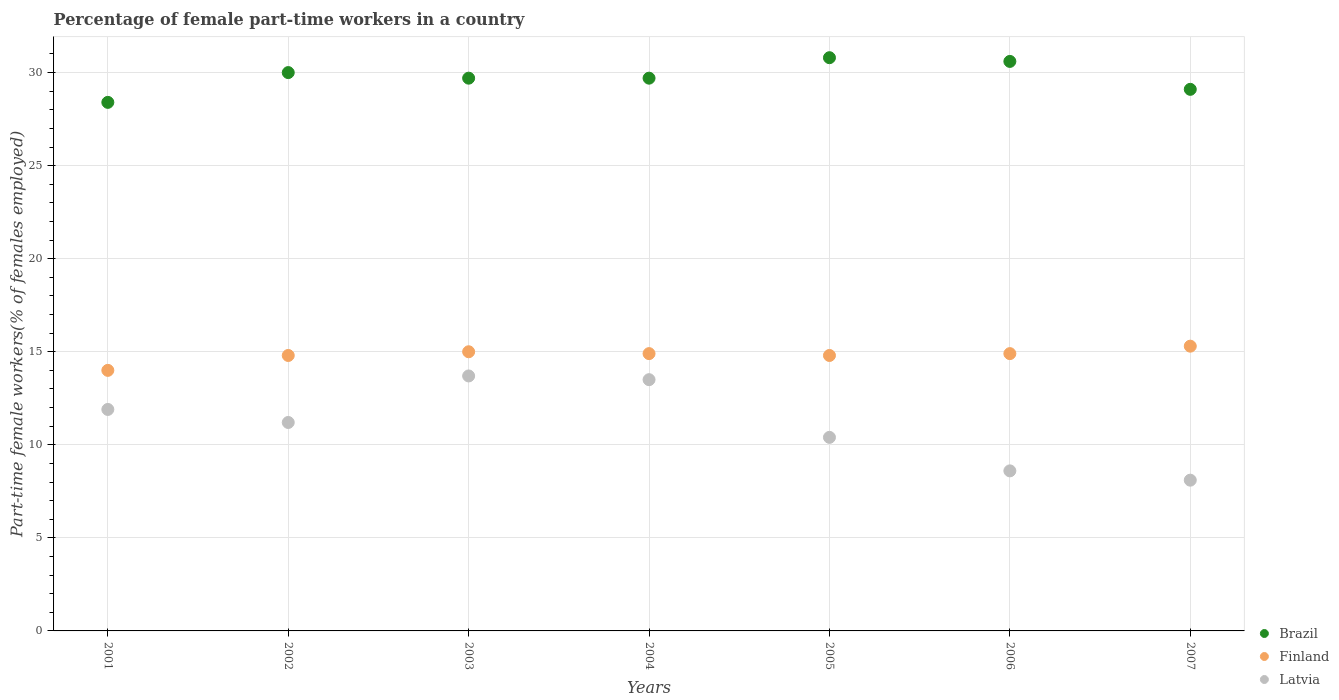How many different coloured dotlines are there?
Your answer should be very brief. 3. Is the number of dotlines equal to the number of legend labels?
Ensure brevity in your answer.  Yes. What is the percentage of female part-time workers in Latvia in 2006?
Provide a succinct answer. 8.6. Across all years, what is the maximum percentage of female part-time workers in Brazil?
Offer a very short reply. 30.8. Across all years, what is the minimum percentage of female part-time workers in Latvia?
Give a very brief answer. 8.1. What is the total percentage of female part-time workers in Latvia in the graph?
Make the answer very short. 77.4. What is the difference between the percentage of female part-time workers in Finland in 2001 and that in 2006?
Your answer should be very brief. -0.9. What is the difference between the percentage of female part-time workers in Finland in 2004 and the percentage of female part-time workers in Brazil in 2002?
Make the answer very short. -15.1. What is the average percentage of female part-time workers in Brazil per year?
Provide a succinct answer. 29.76. In the year 2006, what is the difference between the percentage of female part-time workers in Finland and percentage of female part-time workers in Latvia?
Offer a very short reply. 6.3. In how many years, is the percentage of female part-time workers in Finland greater than 4 %?
Your answer should be very brief. 7. What is the ratio of the percentage of female part-time workers in Latvia in 2004 to that in 2005?
Give a very brief answer. 1.3. Is the percentage of female part-time workers in Latvia in 2001 less than that in 2002?
Ensure brevity in your answer.  No. Is the difference between the percentage of female part-time workers in Finland in 2001 and 2003 greater than the difference between the percentage of female part-time workers in Latvia in 2001 and 2003?
Give a very brief answer. Yes. What is the difference between the highest and the second highest percentage of female part-time workers in Brazil?
Your answer should be very brief. 0.2. What is the difference between the highest and the lowest percentage of female part-time workers in Latvia?
Ensure brevity in your answer.  5.6. In how many years, is the percentage of female part-time workers in Latvia greater than the average percentage of female part-time workers in Latvia taken over all years?
Your response must be concise. 4. Is the sum of the percentage of female part-time workers in Latvia in 2006 and 2007 greater than the maximum percentage of female part-time workers in Finland across all years?
Keep it short and to the point. Yes. Is it the case that in every year, the sum of the percentage of female part-time workers in Latvia and percentage of female part-time workers in Brazil  is greater than the percentage of female part-time workers in Finland?
Your answer should be very brief. Yes. Does the percentage of female part-time workers in Latvia monotonically increase over the years?
Provide a short and direct response. No. Is the percentage of female part-time workers in Brazil strictly greater than the percentage of female part-time workers in Finland over the years?
Provide a succinct answer. Yes. Is the percentage of female part-time workers in Finland strictly less than the percentage of female part-time workers in Brazil over the years?
Ensure brevity in your answer.  Yes. How many years are there in the graph?
Provide a short and direct response. 7. What is the difference between two consecutive major ticks on the Y-axis?
Your response must be concise. 5. Are the values on the major ticks of Y-axis written in scientific E-notation?
Make the answer very short. No. Does the graph contain any zero values?
Your answer should be very brief. No. Where does the legend appear in the graph?
Your response must be concise. Bottom right. How many legend labels are there?
Your answer should be very brief. 3. What is the title of the graph?
Offer a very short reply. Percentage of female part-time workers in a country. Does "Aruba" appear as one of the legend labels in the graph?
Offer a very short reply. No. What is the label or title of the X-axis?
Offer a very short reply. Years. What is the label or title of the Y-axis?
Ensure brevity in your answer.  Part-time female workers(% of females employed). What is the Part-time female workers(% of females employed) of Brazil in 2001?
Provide a short and direct response. 28.4. What is the Part-time female workers(% of females employed) of Finland in 2001?
Give a very brief answer. 14. What is the Part-time female workers(% of females employed) of Latvia in 2001?
Provide a short and direct response. 11.9. What is the Part-time female workers(% of females employed) of Finland in 2002?
Offer a very short reply. 14.8. What is the Part-time female workers(% of females employed) in Latvia in 2002?
Keep it short and to the point. 11.2. What is the Part-time female workers(% of females employed) in Brazil in 2003?
Your answer should be very brief. 29.7. What is the Part-time female workers(% of females employed) in Finland in 2003?
Ensure brevity in your answer.  15. What is the Part-time female workers(% of females employed) in Latvia in 2003?
Keep it short and to the point. 13.7. What is the Part-time female workers(% of females employed) of Brazil in 2004?
Make the answer very short. 29.7. What is the Part-time female workers(% of females employed) in Finland in 2004?
Your answer should be very brief. 14.9. What is the Part-time female workers(% of females employed) in Brazil in 2005?
Keep it short and to the point. 30.8. What is the Part-time female workers(% of females employed) in Finland in 2005?
Offer a terse response. 14.8. What is the Part-time female workers(% of females employed) in Latvia in 2005?
Provide a short and direct response. 10.4. What is the Part-time female workers(% of females employed) in Brazil in 2006?
Your response must be concise. 30.6. What is the Part-time female workers(% of females employed) in Finland in 2006?
Make the answer very short. 14.9. What is the Part-time female workers(% of females employed) of Latvia in 2006?
Your response must be concise. 8.6. What is the Part-time female workers(% of females employed) of Brazil in 2007?
Your answer should be very brief. 29.1. What is the Part-time female workers(% of females employed) of Finland in 2007?
Your answer should be very brief. 15.3. What is the Part-time female workers(% of females employed) of Latvia in 2007?
Give a very brief answer. 8.1. Across all years, what is the maximum Part-time female workers(% of females employed) of Brazil?
Your answer should be very brief. 30.8. Across all years, what is the maximum Part-time female workers(% of females employed) in Finland?
Your answer should be very brief. 15.3. Across all years, what is the maximum Part-time female workers(% of females employed) in Latvia?
Give a very brief answer. 13.7. Across all years, what is the minimum Part-time female workers(% of females employed) of Brazil?
Make the answer very short. 28.4. Across all years, what is the minimum Part-time female workers(% of females employed) of Finland?
Provide a short and direct response. 14. Across all years, what is the minimum Part-time female workers(% of females employed) of Latvia?
Offer a very short reply. 8.1. What is the total Part-time female workers(% of females employed) of Brazil in the graph?
Your response must be concise. 208.3. What is the total Part-time female workers(% of females employed) in Finland in the graph?
Your answer should be compact. 103.7. What is the total Part-time female workers(% of females employed) of Latvia in the graph?
Provide a short and direct response. 77.4. What is the difference between the Part-time female workers(% of females employed) of Latvia in 2001 and that in 2002?
Your answer should be compact. 0.7. What is the difference between the Part-time female workers(% of females employed) in Latvia in 2001 and that in 2006?
Your response must be concise. 3.3. What is the difference between the Part-time female workers(% of females employed) of Finland in 2001 and that in 2007?
Keep it short and to the point. -1.3. What is the difference between the Part-time female workers(% of females employed) in Brazil in 2002 and that in 2003?
Your response must be concise. 0.3. What is the difference between the Part-time female workers(% of females employed) in Latvia in 2002 and that in 2003?
Make the answer very short. -2.5. What is the difference between the Part-time female workers(% of females employed) in Brazil in 2002 and that in 2004?
Your answer should be compact. 0.3. What is the difference between the Part-time female workers(% of females employed) of Latvia in 2002 and that in 2004?
Offer a very short reply. -2.3. What is the difference between the Part-time female workers(% of females employed) in Brazil in 2002 and that in 2005?
Offer a very short reply. -0.8. What is the difference between the Part-time female workers(% of females employed) in Finland in 2002 and that in 2005?
Make the answer very short. 0. What is the difference between the Part-time female workers(% of females employed) of Brazil in 2002 and that in 2006?
Offer a very short reply. -0.6. What is the difference between the Part-time female workers(% of females employed) in Latvia in 2002 and that in 2006?
Your answer should be very brief. 2.6. What is the difference between the Part-time female workers(% of females employed) in Brazil in 2002 and that in 2007?
Offer a very short reply. 0.9. What is the difference between the Part-time female workers(% of females employed) in Brazil in 2003 and that in 2004?
Make the answer very short. 0. What is the difference between the Part-time female workers(% of females employed) of Finland in 2003 and that in 2004?
Provide a short and direct response. 0.1. What is the difference between the Part-time female workers(% of females employed) of Brazil in 2003 and that in 2005?
Your answer should be compact. -1.1. What is the difference between the Part-time female workers(% of females employed) in Finland in 2003 and that in 2005?
Make the answer very short. 0.2. What is the difference between the Part-time female workers(% of females employed) in Finland in 2003 and that in 2006?
Provide a short and direct response. 0.1. What is the difference between the Part-time female workers(% of females employed) in Brazil in 2003 and that in 2007?
Ensure brevity in your answer.  0.6. What is the difference between the Part-time female workers(% of females employed) in Finland in 2004 and that in 2005?
Give a very brief answer. 0.1. What is the difference between the Part-time female workers(% of females employed) of Brazil in 2004 and that in 2006?
Keep it short and to the point. -0.9. What is the difference between the Part-time female workers(% of females employed) in Finland in 2004 and that in 2007?
Make the answer very short. -0.4. What is the difference between the Part-time female workers(% of females employed) in Finland in 2005 and that in 2006?
Offer a terse response. -0.1. What is the difference between the Part-time female workers(% of females employed) of Latvia in 2005 and that in 2006?
Keep it short and to the point. 1.8. What is the difference between the Part-time female workers(% of females employed) in Brazil in 2005 and that in 2007?
Offer a terse response. 1.7. What is the difference between the Part-time female workers(% of females employed) in Finland in 2005 and that in 2007?
Your response must be concise. -0.5. What is the difference between the Part-time female workers(% of females employed) in Brazil in 2006 and that in 2007?
Keep it short and to the point. 1.5. What is the difference between the Part-time female workers(% of females employed) in Brazil in 2001 and the Part-time female workers(% of females employed) in Finland in 2002?
Offer a terse response. 13.6. What is the difference between the Part-time female workers(% of females employed) in Brazil in 2001 and the Part-time female workers(% of females employed) in Latvia in 2003?
Your response must be concise. 14.7. What is the difference between the Part-time female workers(% of females employed) of Finland in 2001 and the Part-time female workers(% of females employed) of Latvia in 2003?
Offer a very short reply. 0.3. What is the difference between the Part-time female workers(% of females employed) of Finland in 2001 and the Part-time female workers(% of females employed) of Latvia in 2004?
Offer a terse response. 0.5. What is the difference between the Part-time female workers(% of females employed) in Finland in 2001 and the Part-time female workers(% of females employed) in Latvia in 2005?
Keep it short and to the point. 3.6. What is the difference between the Part-time female workers(% of females employed) in Brazil in 2001 and the Part-time female workers(% of females employed) in Latvia in 2006?
Give a very brief answer. 19.8. What is the difference between the Part-time female workers(% of females employed) of Finland in 2001 and the Part-time female workers(% of females employed) of Latvia in 2006?
Provide a succinct answer. 5.4. What is the difference between the Part-time female workers(% of females employed) in Brazil in 2001 and the Part-time female workers(% of females employed) in Finland in 2007?
Your answer should be compact. 13.1. What is the difference between the Part-time female workers(% of females employed) in Brazil in 2001 and the Part-time female workers(% of females employed) in Latvia in 2007?
Provide a succinct answer. 20.3. What is the difference between the Part-time female workers(% of females employed) in Finland in 2001 and the Part-time female workers(% of females employed) in Latvia in 2007?
Provide a succinct answer. 5.9. What is the difference between the Part-time female workers(% of females employed) of Brazil in 2002 and the Part-time female workers(% of females employed) of Finland in 2003?
Give a very brief answer. 15. What is the difference between the Part-time female workers(% of females employed) in Brazil in 2002 and the Part-time female workers(% of females employed) in Latvia in 2003?
Your answer should be compact. 16.3. What is the difference between the Part-time female workers(% of females employed) in Finland in 2002 and the Part-time female workers(% of females employed) in Latvia in 2004?
Your answer should be compact. 1.3. What is the difference between the Part-time female workers(% of females employed) of Brazil in 2002 and the Part-time female workers(% of females employed) of Finland in 2005?
Make the answer very short. 15.2. What is the difference between the Part-time female workers(% of females employed) of Brazil in 2002 and the Part-time female workers(% of females employed) of Latvia in 2005?
Offer a terse response. 19.6. What is the difference between the Part-time female workers(% of females employed) of Brazil in 2002 and the Part-time female workers(% of females employed) of Finland in 2006?
Your answer should be very brief. 15.1. What is the difference between the Part-time female workers(% of females employed) in Brazil in 2002 and the Part-time female workers(% of females employed) in Latvia in 2006?
Give a very brief answer. 21.4. What is the difference between the Part-time female workers(% of females employed) in Finland in 2002 and the Part-time female workers(% of females employed) in Latvia in 2006?
Offer a terse response. 6.2. What is the difference between the Part-time female workers(% of females employed) in Brazil in 2002 and the Part-time female workers(% of females employed) in Latvia in 2007?
Provide a succinct answer. 21.9. What is the difference between the Part-time female workers(% of females employed) of Brazil in 2003 and the Part-time female workers(% of females employed) of Finland in 2004?
Keep it short and to the point. 14.8. What is the difference between the Part-time female workers(% of females employed) in Brazil in 2003 and the Part-time female workers(% of females employed) in Latvia in 2004?
Your answer should be very brief. 16.2. What is the difference between the Part-time female workers(% of females employed) in Finland in 2003 and the Part-time female workers(% of females employed) in Latvia in 2004?
Your answer should be very brief. 1.5. What is the difference between the Part-time female workers(% of females employed) in Brazil in 2003 and the Part-time female workers(% of females employed) in Finland in 2005?
Ensure brevity in your answer.  14.9. What is the difference between the Part-time female workers(% of females employed) in Brazil in 2003 and the Part-time female workers(% of females employed) in Latvia in 2005?
Make the answer very short. 19.3. What is the difference between the Part-time female workers(% of females employed) in Brazil in 2003 and the Part-time female workers(% of females employed) in Latvia in 2006?
Your answer should be compact. 21.1. What is the difference between the Part-time female workers(% of females employed) of Brazil in 2003 and the Part-time female workers(% of females employed) of Finland in 2007?
Your response must be concise. 14.4. What is the difference between the Part-time female workers(% of females employed) in Brazil in 2003 and the Part-time female workers(% of females employed) in Latvia in 2007?
Give a very brief answer. 21.6. What is the difference between the Part-time female workers(% of females employed) of Brazil in 2004 and the Part-time female workers(% of females employed) of Latvia in 2005?
Give a very brief answer. 19.3. What is the difference between the Part-time female workers(% of females employed) in Brazil in 2004 and the Part-time female workers(% of females employed) in Latvia in 2006?
Give a very brief answer. 21.1. What is the difference between the Part-time female workers(% of females employed) in Finland in 2004 and the Part-time female workers(% of females employed) in Latvia in 2006?
Provide a succinct answer. 6.3. What is the difference between the Part-time female workers(% of females employed) in Brazil in 2004 and the Part-time female workers(% of females employed) in Finland in 2007?
Your answer should be compact. 14.4. What is the difference between the Part-time female workers(% of females employed) of Brazil in 2004 and the Part-time female workers(% of females employed) of Latvia in 2007?
Offer a terse response. 21.6. What is the difference between the Part-time female workers(% of females employed) of Finland in 2005 and the Part-time female workers(% of females employed) of Latvia in 2006?
Provide a succinct answer. 6.2. What is the difference between the Part-time female workers(% of females employed) of Brazil in 2005 and the Part-time female workers(% of females employed) of Latvia in 2007?
Give a very brief answer. 22.7. What is the average Part-time female workers(% of females employed) of Brazil per year?
Your answer should be very brief. 29.76. What is the average Part-time female workers(% of females employed) of Finland per year?
Your answer should be compact. 14.81. What is the average Part-time female workers(% of females employed) in Latvia per year?
Provide a short and direct response. 11.06. In the year 2001, what is the difference between the Part-time female workers(% of females employed) of Brazil and Part-time female workers(% of females employed) of Latvia?
Make the answer very short. 16.5. In the year 2001, what is the difference between the Part-time female workers(% of females employed) in Finland and Part-time female workers(% of females employed) in Latvia?
Ensure brevity in your answer.  2.1. In the year 2002, what is the difference between the Part-time female workers(% of females employed) of Brazil and Part-time female workers(% of females employed) of Latvia?
Ensure brevity in your answer.  18.8. In the year 2003, what is the difference between the Part-time female workers(% of females employed) in Finland and Part-time female workers(% of females employed) in Latvia?
Provide a short and direct response. 1.3. In the year 2004, what is the difference between the Part-time female workers(% of females employed) in Brazil and Part-time female workers(% of females employed) in Finland?
Offer a terse response. 14.8. In the year 2004, what is the difference between the Part-time female workers(% of females employed) in Brazil and Part-time female workers(% of females employed) in Latvia?
Make the answer very short. 16.2. In the year 2005, what is the difference between the Part-time female workers(% of females employed) of Brazil and Part-time female workers(% of females employed) of Finland?
Ensure brevity in your answer.  16. In the year 2005, what is the difference between the Part-time female workers(% of females employed) in Brazil and Part-time female workers(% of females employed) in Latvia?
Your response must be concise. 20.4. In the year 2006, what is the difference between the Part-time female workers(% of females employed) in Finland and Part-time female workers(% of females employed) in Latvia?
Make the answer very short. 6.3. In the year 2007, what is the difference between the Part-time female workers(% of females employed) of Brazil and Part-time female workers(% of females employed) of Latvia?
Provide a short and direct response. 21. In the year 2007, what is the difference between the Part-time female workers(% of females employed) in Finland and Part-time female workers(% of females employed) in Latvia?
Give a very brief answer. 7.2. What is the ratio of the Part-time female workers(% of females employed) of Brazil in 2001 to that in 2002?
Make the answer very short. 0.95. What is the ratio of the Part-time female workers(% of females employed) in Finland in 2001 to that in 2002?
Your answer should be very brief. 0.95. What is the ratio of the Part-time female workers(% of females employed) in Latvia in 2001 to that in 2002?
Your answer should be very brief. 1.06. What is the ratio of the Part-time female workers(% of females employed) of Brazil in 2001 to that in 2003?
Make the answer very short. 0.96. What is the ratio of the Part-time female workers(% of females employed) in Finland in 2001 to that in 2003?
Ensure brevity in your answer.  0.93. What is the ratio of the Part-time female workers(% of females employed) of Latvia in 2001 to that in 2003?
Provide a short and direct response. 0.87. What is the ratio of the Part-time female workers(% of females employed) of Brazil in 2001 to that in 2004?
Offer a very short reply. 0.96. What is the ratio of the Part-time female workers(% of females employed) of Finland in 2001 to that in 2004?
Your response must be concise. 0.94. What is the ratio of the Part-time female workers(% of females employed) of Latvia in 2001 to that in 2004?
Your answer should be very brief. 0.88. What is the ratio of the Part-time female workers(% of females employed) in Brazil in 2001 to that in 2005?
Your answer should be very brief. 0.92. What is the ratio of the Part-time female workers(% of females employed) of Finland in 2001 to that in 2005?
Make the answer very short. 0.95. What is the ratio of the Part-time female workers(% of females employed) of Latvia in 2001 to that in 2005?
Give a very brief answer. 1.14. What is the ratio of the Part-time female workers(% of females employed) of Brazil in 2001 to that in 2006?
Provide a succinct answer. 0.93. What is the ratio of the Part-time female workers(% of females employed) of Finland in 2001 to that in 2006?
Your answer should be compact. 0.94. What is the ratio of the Part-time female workers(% of females employed) in Latvia in 2001 to that in 2006?
Offer a terse response. 1.38. What is the ratio of the Part-time female workers(% of females employed) in Brazil in 2001 to that in 2007?
Offer a terse response. 0.98. What is the ratio of the Part-time female workers(% of females employed) of Finland in 2001 to that in 2007?
Give a very brief answer. 0.92. What is the ratio of the Part-time female workers(% of females employed) in Latvia in 2001 to that in 2007?
Your response must be concise. 1.47. What is the ratio of the Part-time female workers(% of females employed) in Finland in 2002 to that in 2003?
Your answer should be compact. 0.99. What is the ratio of the Part-time female workers(% of females employed) in Latvia in 2002 to that in 2003?
Your answer should be very brief. 0.82. What is the ratio of the Part-time female workers(% of females employed) of Brazil in 2002 to that in 2004?
Keep it short and to the point. 1.01. What is the ratio of the Part-time female workers(% of females employed) in Finland in 2002 to that in 2004?
Your response must be concise. 0.99. What is the ratio of the Part-time female workers(% of females employed) of Latvia in 2002 to that in 2004?
Offer a terse response. 0.83. What is the ratio of the Part-time female workers(% of females employed) of Brazil in 2002 to that in 2006?
Provide a succinct answer. 0.98. What is the ratio of the Part-time female workers(% of females employed) in Finland in 2002 to that in 2006?
Ensure brevity in your answer.  0.99. What is the ratio of the Part-time female workers(% of females employed) in Latvia in 2002 to that in 2006?
Ensure brevity in your answer.  1.3. What is the ratio of the Part-time female workers(% of females employed) in Brazil in 2002 to that in 2007?
Keep it short and to the point. 1.03. What is the ratio of the Part-time female workers(% of females employed) in Finland in 2002 to that in 2007?
Offer a terse response. 0.97. What is the ratio of the Part-time female workers(% of females employed) of Latvia in 2002 to that in 2007?
Provide a short and direct response. 1.38. What is the ratio of the Part-time female workers(% of females employed) in Finland in 2003 to that in 2004?
Ensure brevity in your answer.  1.01. What is the ratio of the Part-time female workers(% of females employed) of Latvia in 2003 to that in 2004?
Offer a terse response. 1.01. What is the ratio of the Part-time female workers(% of females employed) of Brazil in 2003 to that in 2005?
Keep it short and to the point. 0.96. What is the ratio of the Part-time female workers(% of females employed) of Finland in 2003 to that in 2005?
Your answer should be compact. 1.01. What is the ratio of the Part-time female workers(% of females employed) of Latvia in 2003 to that in 2005?
Give a very brief answer. 1.32. What is the ratio of the Part-time female workers(% of females employed) in Brazil in 2003 to that in 2006?
Your answer should be compact. 0.97. What is the ratio of the Part-time female workers(% of females employed) of Latvia in 2003 to that in 2006?
Provide a succinct answer. 1.59. What is the ratio of the Part-time female workers(% of females employed) in Brazil in 2003 to that in 2007?
Your answer should be very brief. 1.02. What is the ratio of the Part-time female workers(% of females employed) in Finland in 2003 to that in 2007?
Your answer should be compact. 0.98. What is the ratio of the Part-time female workers(% of females employed) in Latvia in 2003 to that in 2007?
Provide a succinct answer. 1.69. What is the ratio of the Part-time female workers(% of females employed) of Brazil in 2004 to that in 2005?
Provide a short and direct response. 0.96. What is the ratio of the Part-time female workers(% of females employed) in Finland in 2004 to that in 2005?
Give a very brief answer. 1.01. What is the ratio of the Part-time female workers(% of females employed) of Latvia in 2004 to that in 2005?
Your answer should be compact. 1.3. What is the ratio of the Part-time female workers(% of females employed) of Brazil in 2004 to that in 2006?
Your response must be concise. 0.97. What is the ratio of the Part-time female workers(% of females employed) in Latvia in 2004 to that in 2006?
Your response must be concise. 1.57. What is the ratio of the Part-time female workers(% of females employed) in Brazil in 2004 to that in 2007?
Offer a very short reply. 1.02. What is the ratio of the Part-time female workers(% of females employed) of Finland in 2004 to that in 2007?
Your answer should be compact. 0.97. What is the ratio of the Part-time female workers(% of females employed) in Latvia in 2005 to that in 2006?
Ensure brevity in your answer.  1.21. What is the ratio of the Part-time female workers(% of females employed) in Brazil in 2005 to that in 2007?
Offer a terse response. 1.06. What is the ratio of the Part-time female workers(% of females employed) of Finland in 2005 to that in 2007?
Give a very brief answer. 0.97. What is the ratio of the Part-time female workers(% of females employed) in Latvia in 2005 to that in 2007?
Provide a succinct answer. 1.28. What is the ratio of the Part-time female workers(% of females employed) of Brazil in 2006 to that in 2007?
Provide a succinct answer. 1.05. What is the ratio of the Part-time female workers(% of females employed) in Finland in 2006 to that in 2007?
Make the answer very short. 0.97. What is the ratio of the Part-time female workers(% of females employed) in Latvia in 2006 to that in 2007?
Your answer should be very brief. 1.06. What is the difference between the highest and the second highest Part-time female workers(% of females employed) of Brazil?
Provide a succinct answer. 0.2. What is the difference between the highest and the second highest Part-time female workers(% of females employed) of Finland?
Ensure brevity in your answer.  0.3. What is the difference between the highest and the lowest Part-time female workers(% of females employed) in Brazil?
Provide a short and direct response. 2.4. What is the difference between the highest and the lowest Part-time female workers(% of females employed) of Finland?
Ensure brevity in your answer.  1.3. What is the difference between the highest and the lowest Part-time female workers(% of females employed) of Latvia?
Your response must be concise. 5.6. 